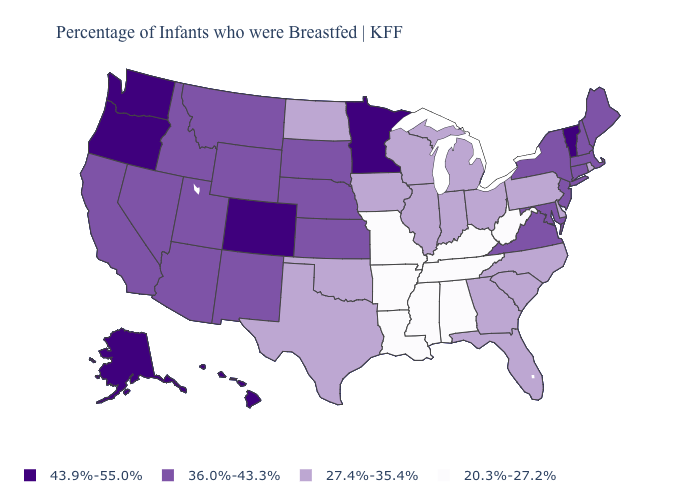What is the value of South Dakota?
Give a very brief answer. 36.0%-43.3%. What is the value of Nevada?
Write a very short answer. 36.0%-43.3%. Name the states that have a value in the range 20.3%-27.2%?
Give a very brief answer. Alabama, Arkansas, Kentucky, Louisiana, Mississippi, Missouri, Tennessee, West Virginia. Is the legend a continuous bar?
Short answer required. No. What is the value of Missouri?
Give a very brief answer. 20.3%-27.2%. What is the value of Rhode Island?
Quick response, please. 27.4%-35.4%. Does Vermont have the highest value in the USA?
Write a very short answer. Yes. Name the states that have a value in the range 20.3%-27.2%?
Concise answer only. Alabama, Arkansas, Kentucky, Louisiana, Mississippi, Missouri, Tennessee, West Virginia. Which states have the lowest value in the USA?
Answer briefly. Alabama, Arkansas, Kentucky, Louisiana, Mississippi, Missouri, Tennessee, West Virginia. Does Hawaii have the highest value in the USA?
Write a very short answer. Yes. Name the states that have a value in the range 36.0%-43.3%?
Concise answer only. Arizona, California, Connecticut, Idaho, Kansas, Maine, Maryland, Massachusetts, Montana, Nebraska, Nevada, New Hampshire, New Jersey, New Mexico, New York, South Dakota, Utah, Virginia, Wyoming. Does Texas have the lowest value in the USA?
Quick response, please. No. What is the value of Alaska?
Keep it brief. 43.9%-55.0%. What is the lowest value in the South?
Give a very brief answer. 20.3%-27.2%. What is the value of Mississippi?
Answer briefly. 20.3%-27.2%. 